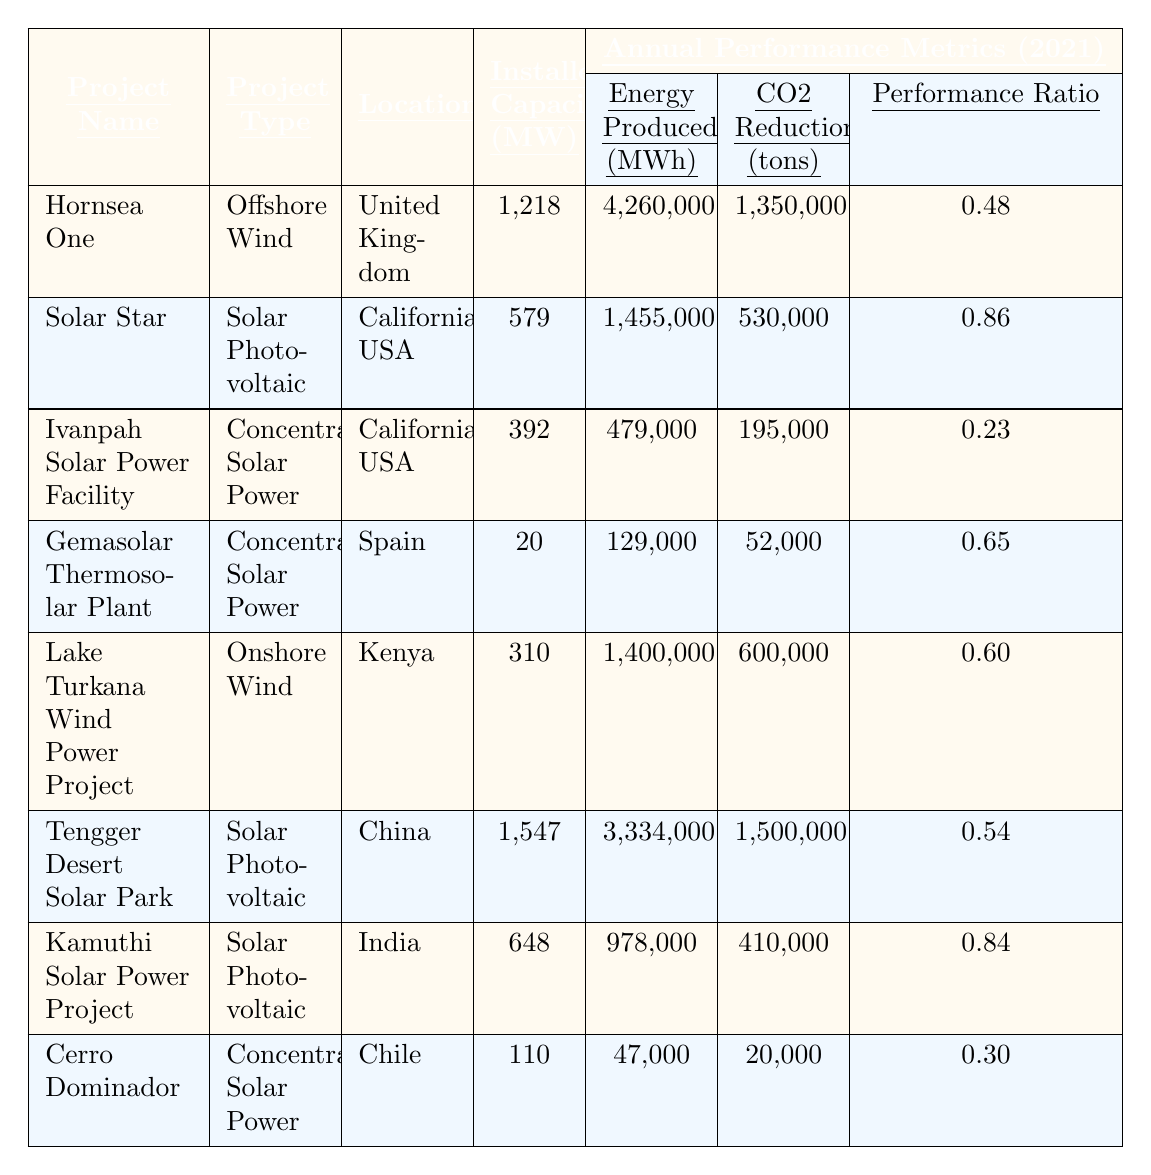What is the installed capacity of the "Hornsea One" project? The table lists "Hornsea One" with an installed capacity of 1,218 MW in the respective column.
Answer: 1,218 MW Which project produced the most energy in MWh? By comparing the "Energy Produced (MWh)" column, the "Hornsea One" project produced 4,260,000 MWh, the highest among all projects listed.
Answer: Hornsea One What is the CO2 reduction of the "Kamuthi Solar Power Project"? Referring to the "CO2 Reduction (tons)" column, the "Kamuthi Solar Power Project" has a CO2 reduction of 410,000 tons.
Answer: 410,000 tons Which project has the lowest annual performance ratio? The "Annual Performance Ratio" column shows that "Ivanpah Solar Power Facility" has the lowest value at 0.23.
Answer: 0.23 What is the average energy produced by all projects listed in the table? Sum the energy produced: 4,260,000 + 1,455,000 + 479,000 + 129,000 + 1,400,000 + 3,334,000 + 978,000 + 47,000 = 11,182,000 MWh. There are 8 projects, so the average is 11,182,000 / 8 = 1,397,750 MWh.
Answer: 1,397,750 MWh Is the annual performance ratio of the "Tengger Desert Solar Park" greater than 0.5? Looking at the "Annual Performance Ratio" column, the value for "Tengger Desert Solar Park" is 0.54, which is greater than 0.5.
Answer: Yes What is the total CO2 reduction achieved by all projects combined? Adding the values from the "CO2 Reduction (tons)" column gives: 1,350,000 + 530,000 + 195,000 + 52,000 + 600,000 + 1,500,000 + 410,000 + 20,000 = 4,657,000 tons.
Answer: 4,657,000 tons What percentage of total energy produced is attributed to the "Solar Star" project? First, find total energy produced (11,182,000 MWh) and then find the proportion from "Solar Star": (1,455,000 / 11,182,000) * 100 = 12.99%.
Answer: Approximately 13% Which type of renewable energy project has the highest average performance ratio? Calculate the average performance ratio for each type: Offshore Wind (0.48), Solar Photovoltaic [(0.86 + 0.84 + 0.54) / 3 = 0.775], Concentrated Solar Power [(0.23 + 0.65 + 0.30) / 3 = 0.393], Onshore Wind (0.60). The highest is Solar Photovoltaic with 0.775.
Answer: Solar Photovoltaic Which project's CO2 reduction is closest to 600,000 tons? Reviewing the "CO2 Reduction (tons)" column, the "Lake Turkana Wind Power Project" has a value of 600,000 tons, which matches exactly.
Answer: Lake Turkana Wind Power Project 